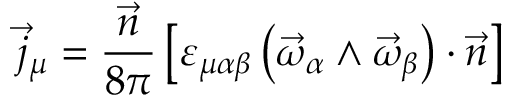Convert formula to latex. <formula><loc_0><loc_0><loc_500><loc_500>\vec { j } _ { \mu } = \frac { \vec { n } } { 8 \pi } \left [ \varepsilon _ { \mu \alpha \beta } \left ( \vec { \omega } _ { \alpha } \wedge \vec { \omega } _ { \beta } \right ) \cdot \vec { n } \right ]</formula> 